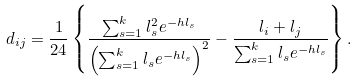Convert formula to latex. <formula><loc_0><loc_0><loc_500><loc_500>d _ { i j } = \frac { 1 } { 2 4 } \left \{ \frac { \sum _ { s = 1 } ^ { k } l _ { s } ^ { 2 } e ^ { - h l _ { s } } } { \left ( \sum _ { s = 1 } ^ { k } l _ { s } e ^ { - h l _ { s } } \right ) ^ { 2 } } - \frac { l _ { i } + l _ { j } } { \sum _ { s = 1 } ^ { k } l _ { s } e ^ { - h l _ { s } } } \right \} .</formula> 